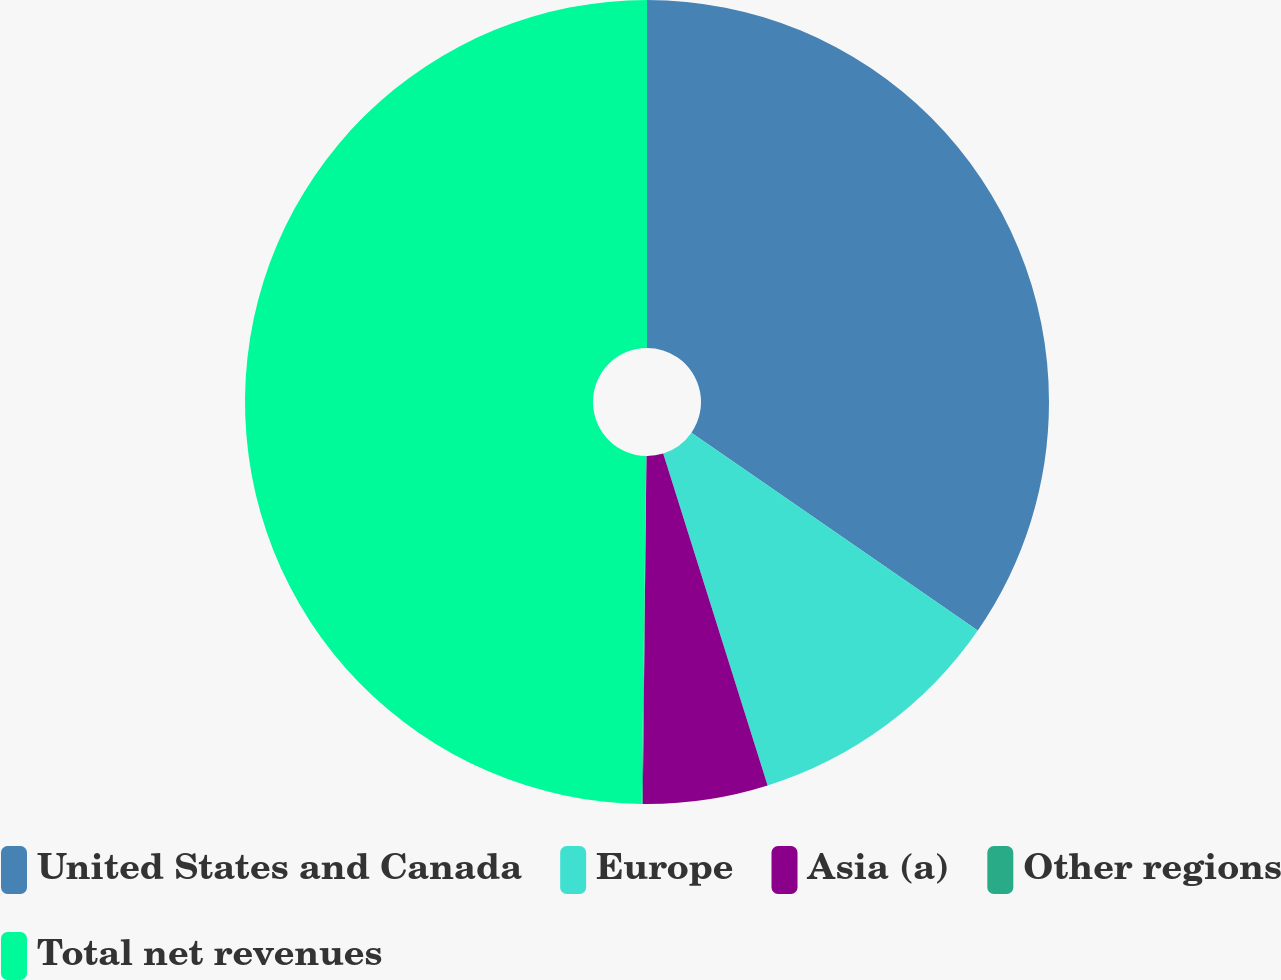<chart> <loc_0><loc_0><loc_500><loc_500><pie_chart><fcel>United States and Canada<fcel>Europe<fcel>Asia (a)<fcel>Other regions<fcel>Total net revenues<nl><fcel>34.62%<fcel>10.53%<fcel>5.02%<fcel>0.04%<fcel>49.79%<nl></chart> 